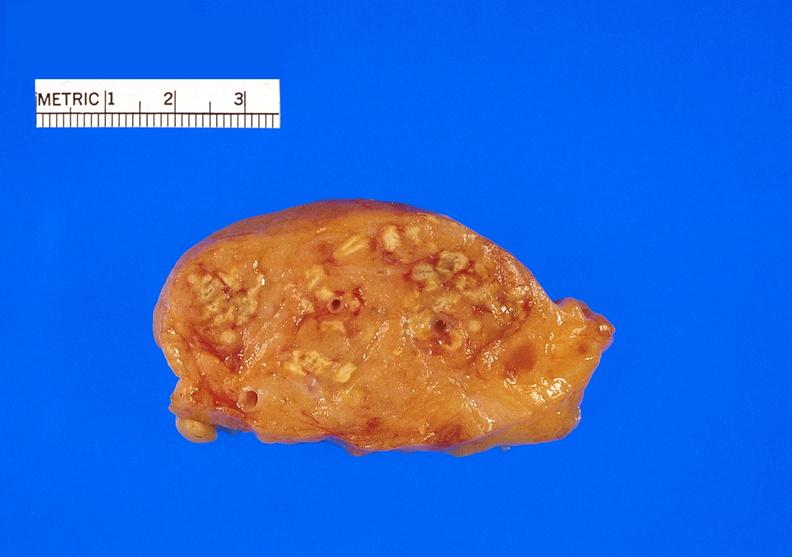what does this image show?
Answer the question using a single word or phrase. Pancreatic fat necrosis 